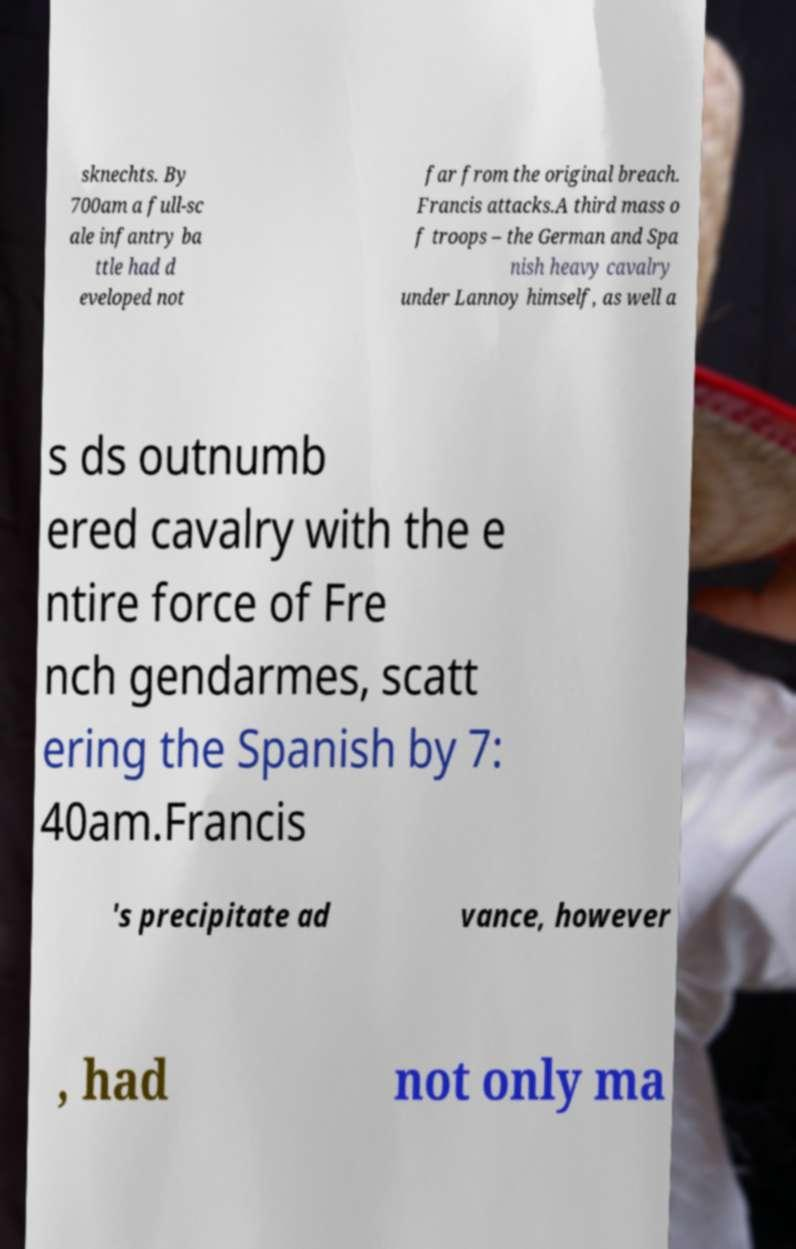What messages or text are displayed in this image? I need them in a readable, typed format. sknechts. By 700am a full-sc ale infantry ba ttle had d eveloped not far from the original breach. Francis attacks.A third mass o f troops – the German and Spa nish heavy cavalry under Lannoy himself, as well a s ds outnumb ered cavalry with the e ntire force of Fre nch gendarmes, scatt ering the Spanish by 7: 40am.Francis 's precipitate ad vance, however , had not only ma 